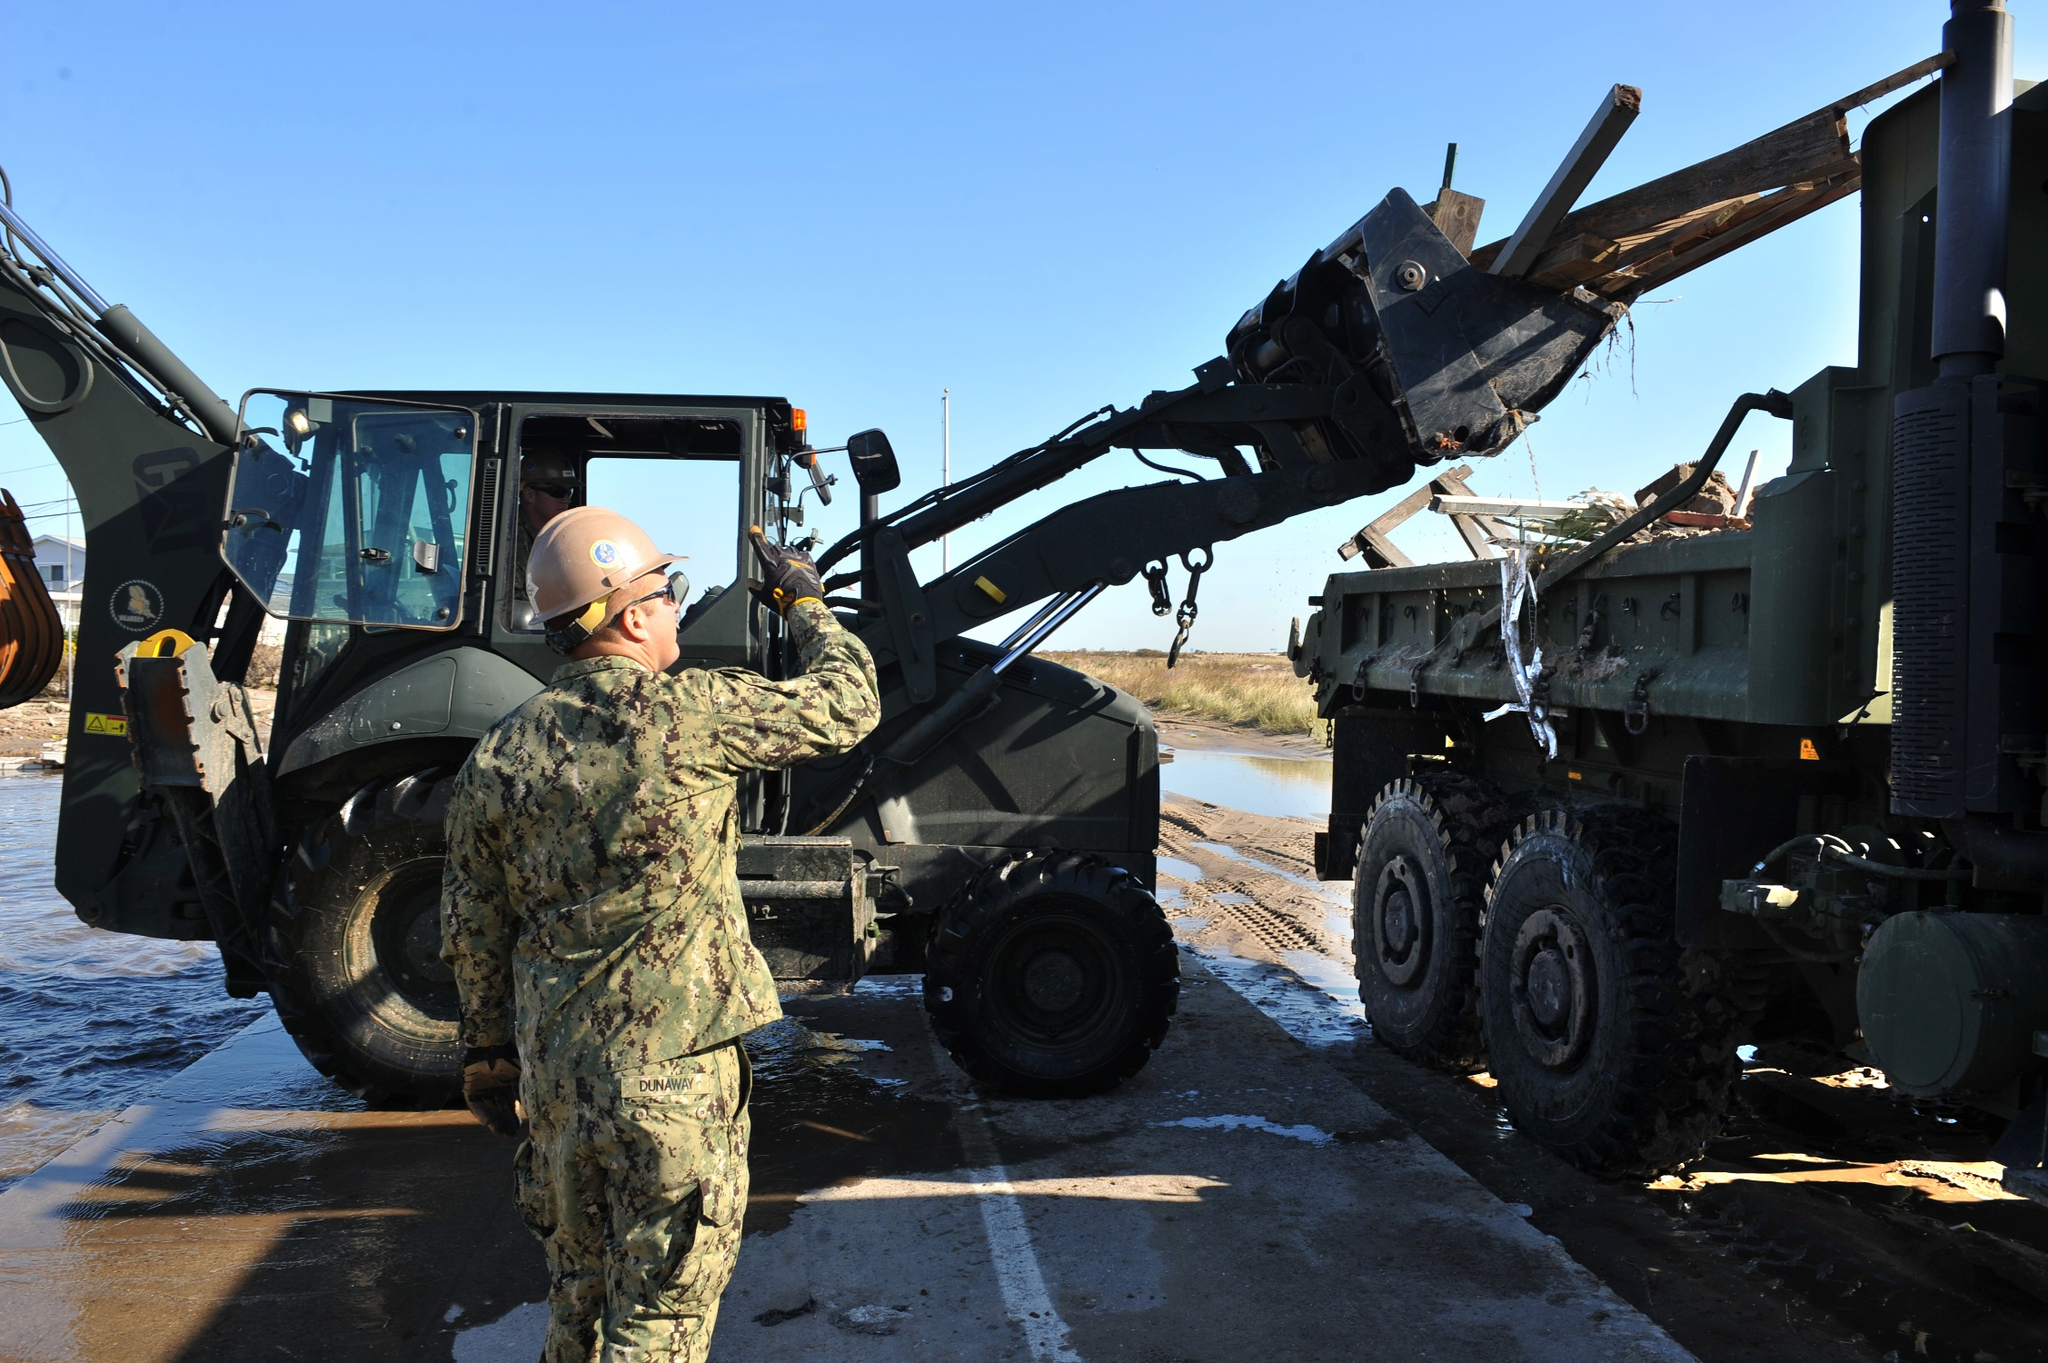If you had to imagine a story or scenario happening around this image, what would it be? In a peaceful coastal area, the military is supporting a critical infrastructure project to rebuild after a natural disaster. The wooden beams being moved by the forklift are crucial components for the restoration of a bridge that connects remote villages to the main town. The worker, a seasoned veteran, has seen many such operations but remains passionately dedicated to ensuring everything is done perfectly. The water’s calmness contrasts with the urgency of their mission, tying nature’s tranquility with human resilience and effort. 